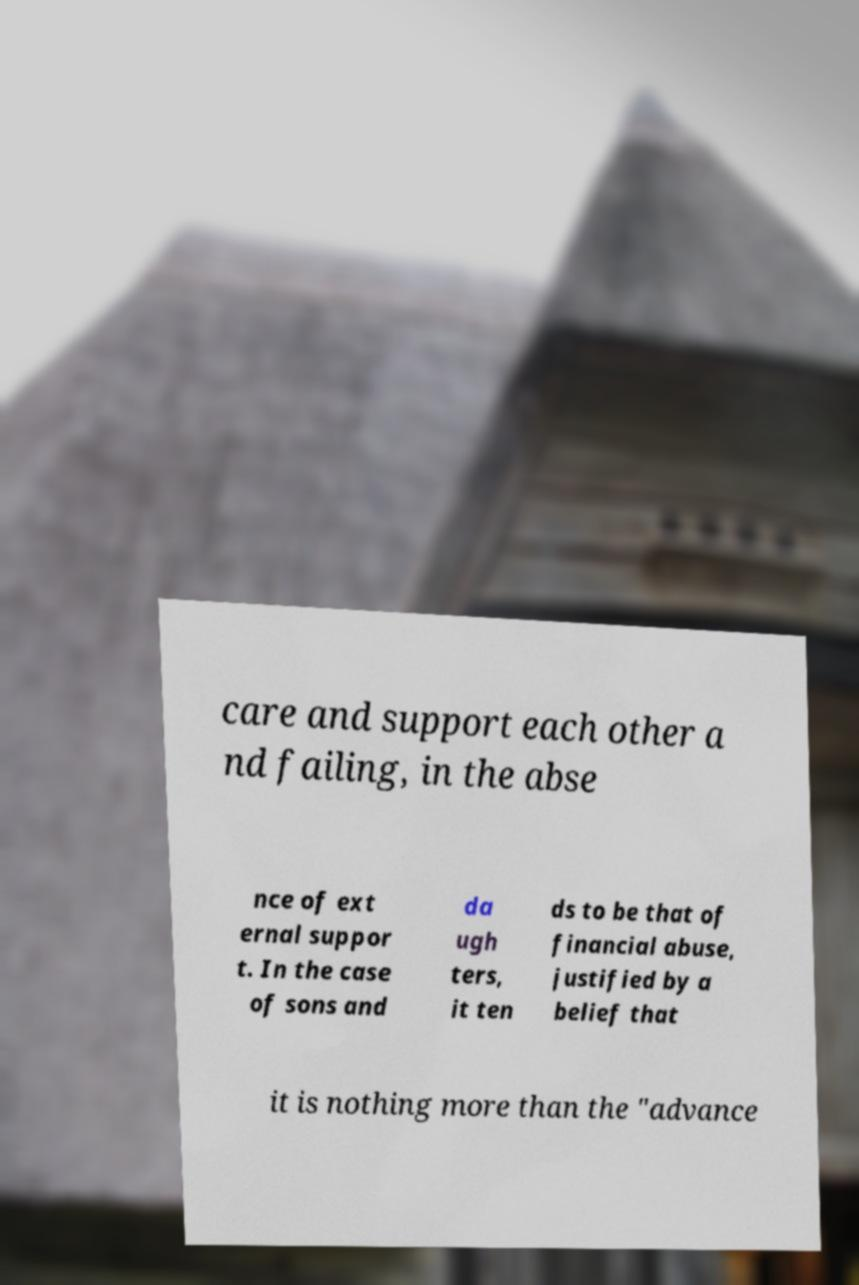I need the written content from this picture converted into text. Can you do that? care and support each other a nd failing, in the abse nce of ext ernal suppor t. In the case of sons and da ugh ters, it ten ds to be that of financial abuse, justified by a belief that it is nothing more than the "advance 